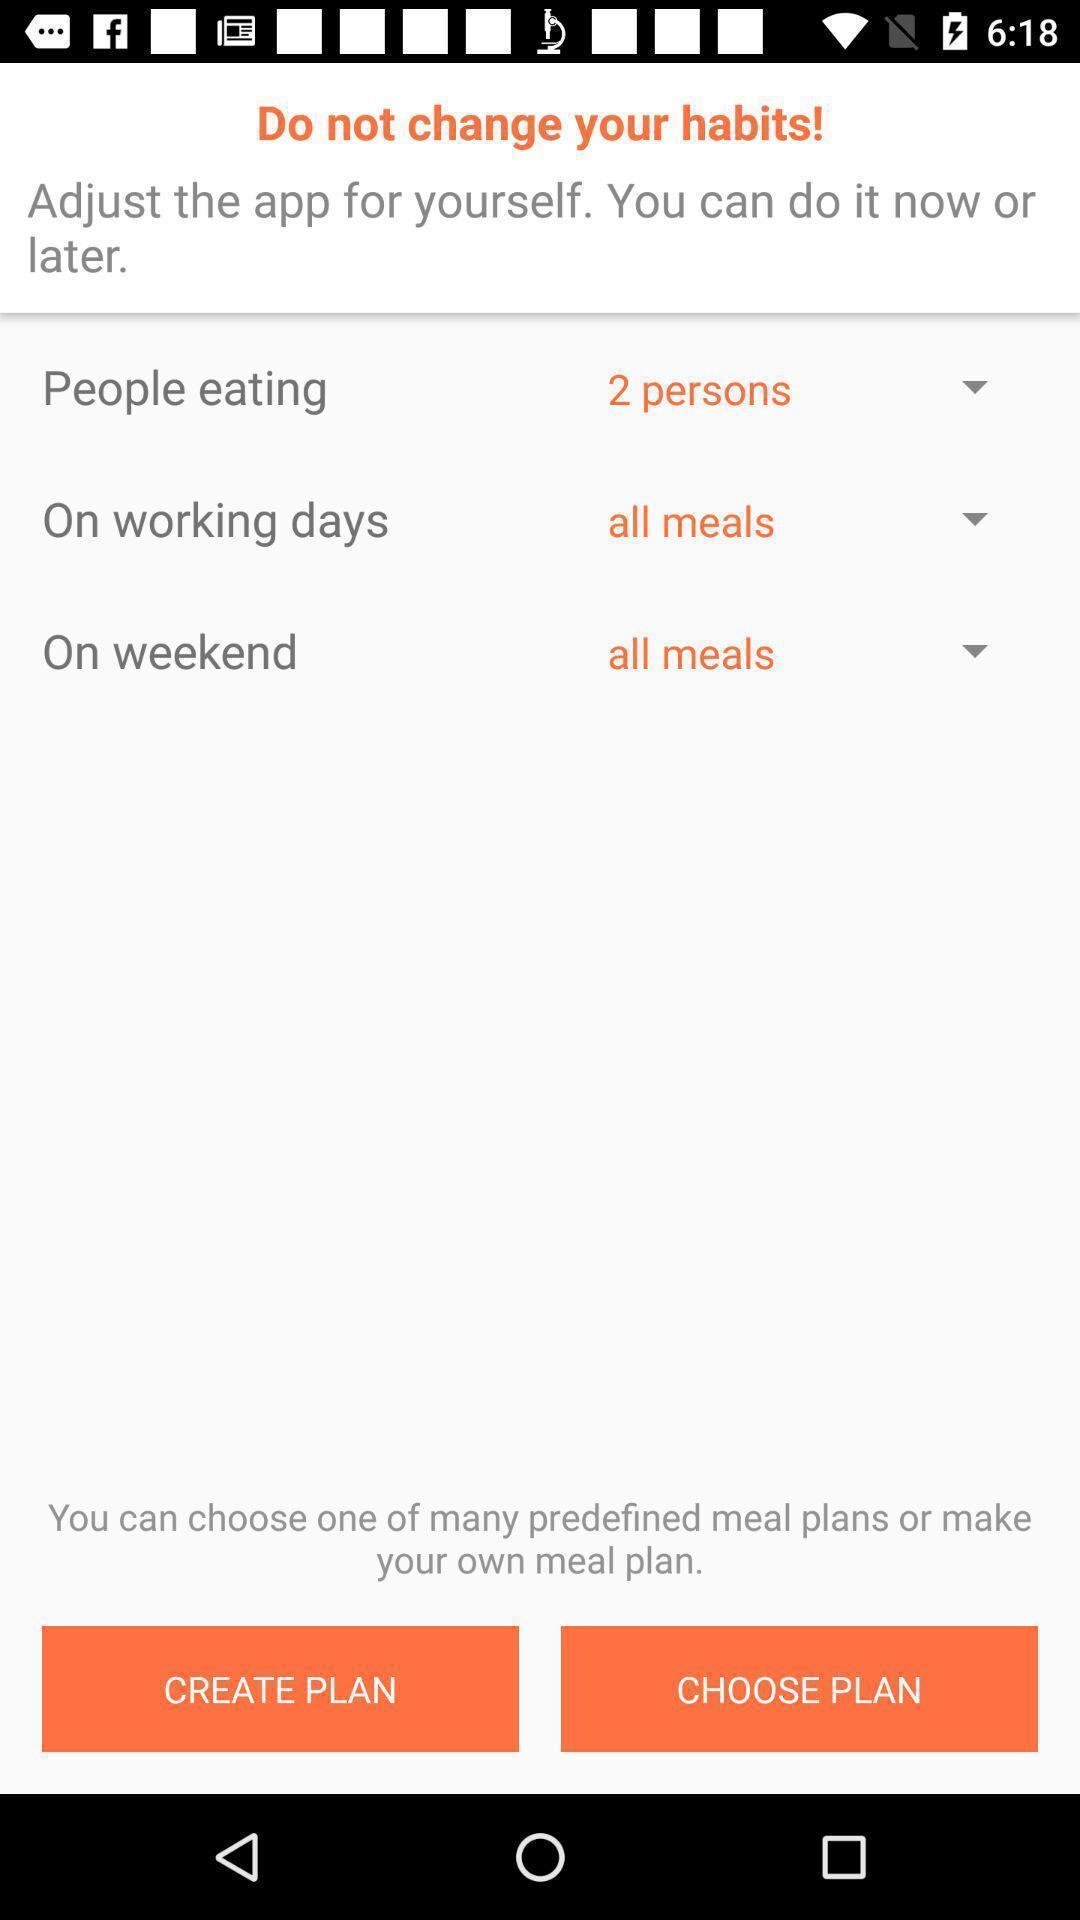Give me a summary of this screen capture. Screen showing create meal plan. 